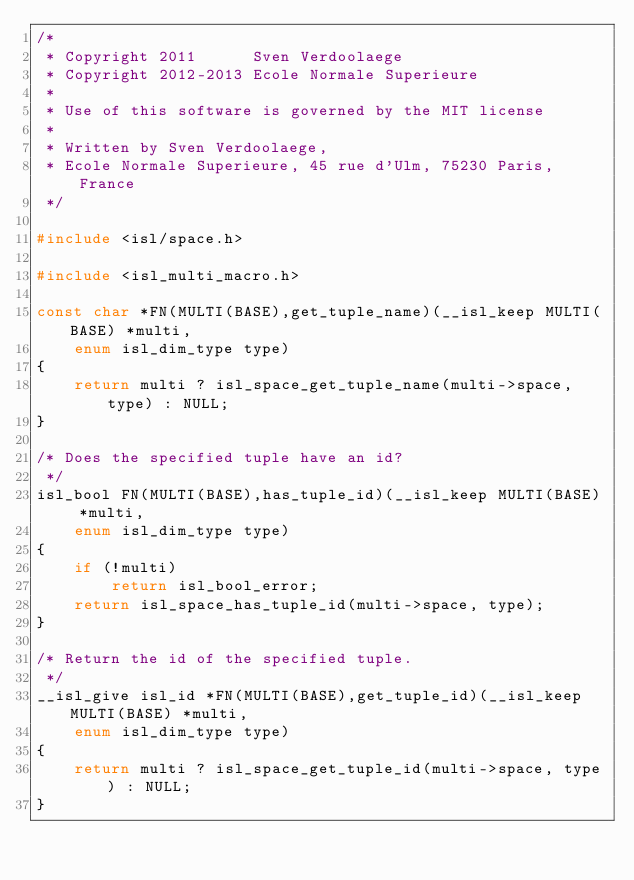Convert code to text. <code><loc_0><loc_0><loc_500><loc_500><_C_>/*
 * Copyright 2011      Sven Verdoolaege
 * Copyright 2012-2013 Ecole Normale Superieure
 *
 * Use of this software is governed by the MIT license
 *
 * Written by Sven Verdoolaege,
 * Ecole Normale Superieure, 45 rue d'Ulm, 75230 Paris, France
 */

#include <isl/space.h>

#include <isl_multi_macro.h>

const char *FN(MULTI(BASE),get_tuple_name)(__isl_keep MULTI(BASE) *multi,
	enum isl_dim_type type)
{
	return multi ? isl_space_get_tuple_name(multi->space, type) : NULL;
}

/* Does the specified tuple have an id?
 */
isl_bool FN(MULTI(BASE),has_tuple_id)(__isl_keep MULTI(BASE) *multi,
	enum isl_dim_type type)
{
	if (!multi)
		return isl_bool_error;
	return isl_space_has_tuple_id(multi->space, type);
}

/* Return the id of the specified tuple.
 */
__isl_give isl_id *FN(MULTI(BASE),get_tuple_id)(__isl_keep MULTI(BASE) *multi,
	enum isl_dim_type type)
{
	return multi ? isl_space_get_tuple_id(multi->space, type) : NULL;
}
</code> 